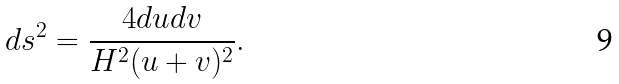Convert formula to latex. <formula><loc_0><loc_0><loc_500><loc_500>d s ^ { 2 } = \frac { 4 d u d v } { H ^ { 2 } ( u + v ) ^ { 2 } } .</formula> 